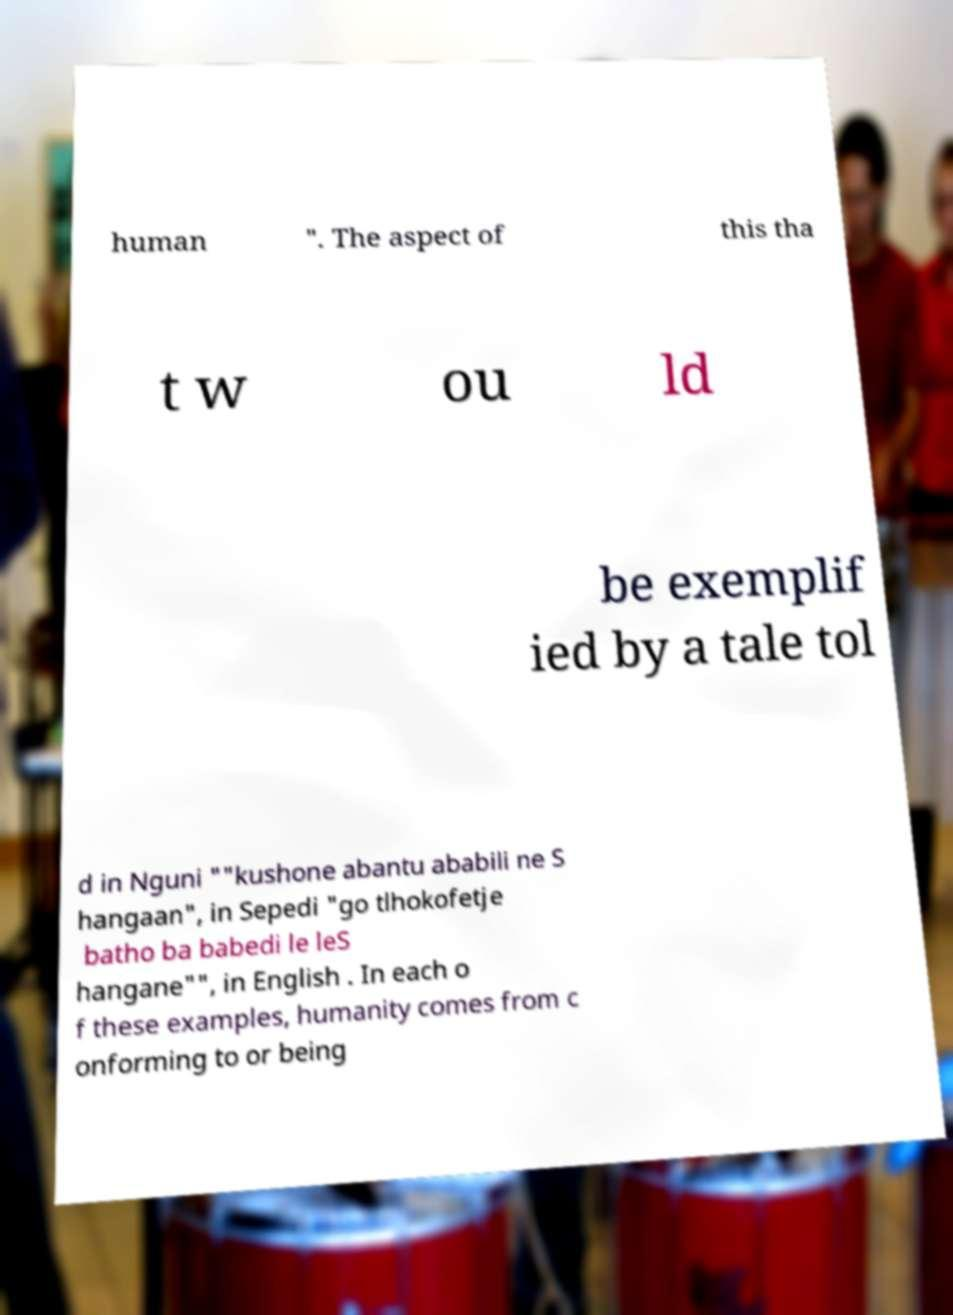Could you extract and type out the text from this image? human ". The aspect of this tha t w ou ld be exemplif ied by a tale tol d in Nguni ""kushone abantu ababili ne S hangaan", in Sepedi "go tlhokofetje batho ba babedi le leS hangane"", in English . In each o f these examples, humanity comes from c onforming to or being 